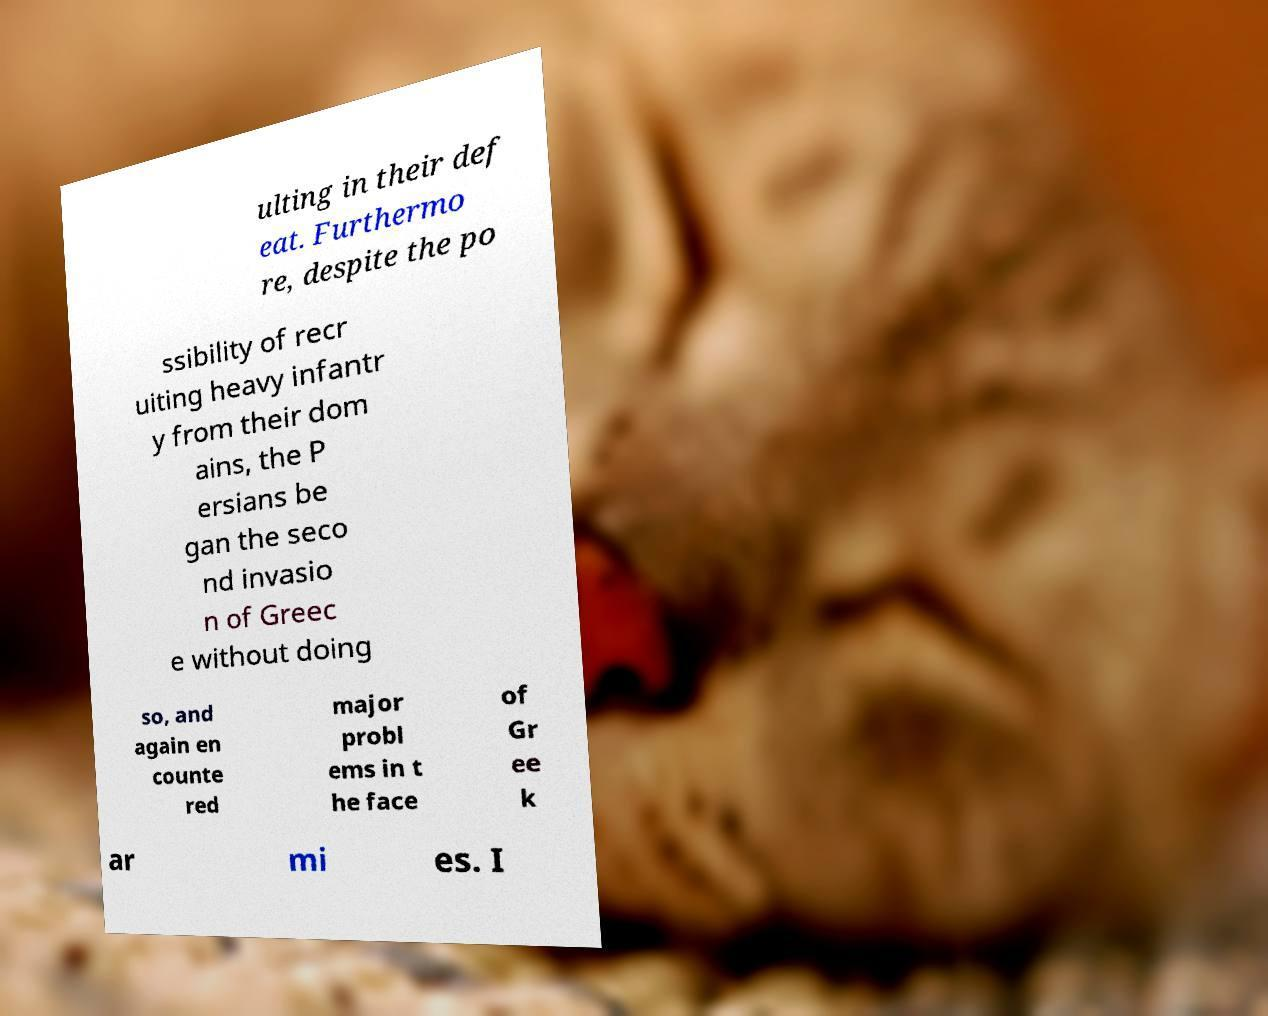Could you extract and type out the text from this image? ulting in their def eat. Furthermo re, despite the po ssibility of recr uiting heavy infantr y from their dom ains, the P ersians be gan the seco nd invasio n of Greec e without doing so, and again en counte red major probl ems in t he face of Gr ee k ar mi es. I 